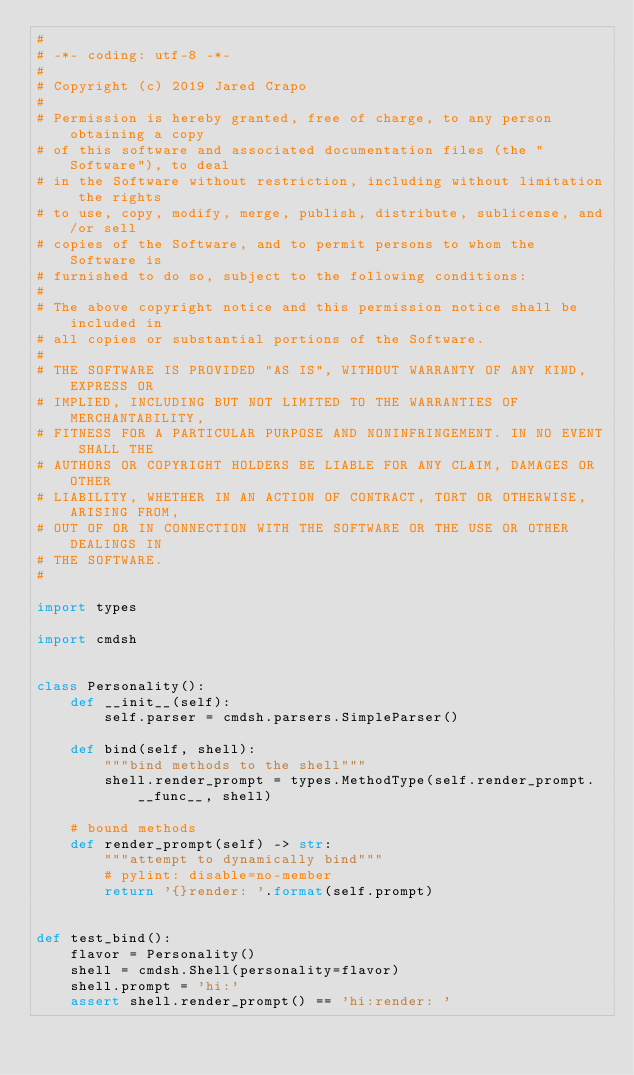Convert code to text. <code><loc_0><loc_0><loc_500><loc_500><_Python_>#
# -*- coding: utf-8 -*-
#
# Copyright (c) 2019 Jared Crapo
#
# Permission is hereby granted, free of charge, to any person obtaining a copy
# of this software and associated documentation files (the "Software"), to deal
# in the Software without restriction, including without limitation the rights
# to use, copy, modify, merge, publish, distribute, sublicense, and/or sell
# copies of the Software, and to permit persons to whom the Software is
# furnished to do so, subject to the following conditions:
#
# The above copyright notice and this permission notice shall be included in
# all copies or substantial portions of the Software.
#
# THE SOFTWARE IS PROVIDED "AS IS", WITHOUT WARRANTY OF ANY KIND, EXPRESS OR
# IMPLIED, INCLUDING BUT NOT LIMITED TO THE WARRANTIES OF MERCHANTABILITY,
# FITNESS FOR A PARTICULAR PURPOSE AND NONINFRINGEMENT. IN NO EVENT SHALL THE
# AUTHORS OR COPYRIGHT HOLDERS BE LIABLE FOR ANY CLAIM, DAMAGES OR OTHER
# LIABILITY, WHETHER IN AN ACTION OF CONTRACT, TORT OR OTHERWISE, ARISING FROM,
# OUT OF OR IN CONNECTION WITH THE SOFTWARE OR THE USE OR OTHER DEALINGS IN
# THE SOFTWARE.
#

import types

import cmdsh


class Personality():
    def __init__(self):
        self.parser = cmdsh.parsers.SimpleParser()

    def bind(self, shell):
        """bind methods to the shell"""
        shell.render_prompt = types.MethodType(self.render_prompt.__func__, shell)

    # bound methods
    def render_prompt(self) -> str:
        """attempt to dynamically bind"""
        # pylint: disable=no-member
        return '{}render: '.format(self.prompt)


def test_bind():
    flavor = Personality()
    shell = cmdsh.Shell(personality=flavor)
    shell.prompt = 'hi:'
    assert shell.render_prompt() == 'hi:render: '
</code> 